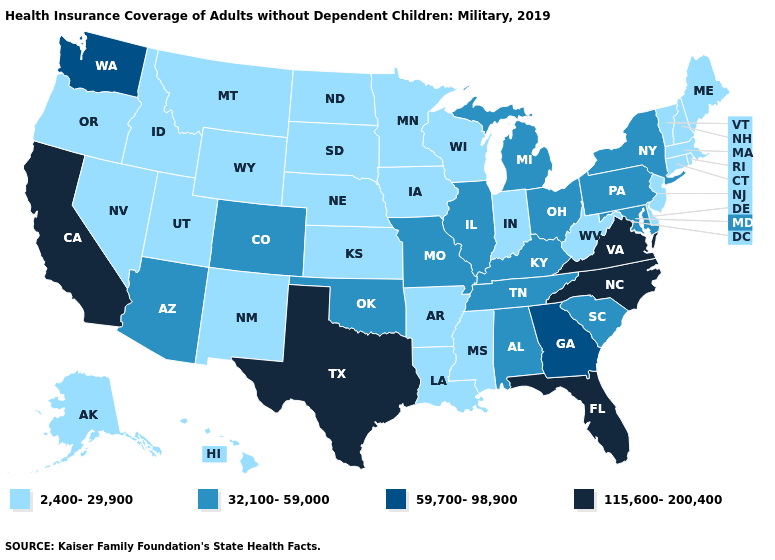What is the lowest value in states that border Louisiana?
Keep it brief. 2,400-29,900. Does Texas have the highest value in the South?
Concise answer only. Yes. What is the lowest value in states that border Ohio?
Keep it brief. 2,400-29,900. Which states hav the highest value in the Northeast?
Short answer required. New York, Pennsylvania. What is the highest value in the USA?
Be succinct. 115,600-200,400. What is the value of Nevada?
Give a very brief answer. 2,400-29,900. Name the states that have a value in the range 59,700-98,900?
Write a very short answer. Georgia, Washington. Which states have the highest value in the USA?
Answer briefly. California, Florida, North Carolina, Texas, Virginia. How many symbols are there in the legend?
Be succinct. 4. Does the first symbol in the legend represent the smallest category?
Short answer required. Yes. How many symbols are there in the legend?
Concise answer only. 4. Does Virginia have the same value as West Virginia?
Short answer required. No. Does the first symbol in the legend represent the smallest category?
Write a very short answer. Yes. Name the states that have a value in the range 32,100-59,000?
Be succinct. Alabama, Arizona, Colorado, Illinois, Kentucky, Maryland, Michigan, Missouri, New York, Ohio, Oklahoma, Pennsylvania, South Carolina, Tennessee. 